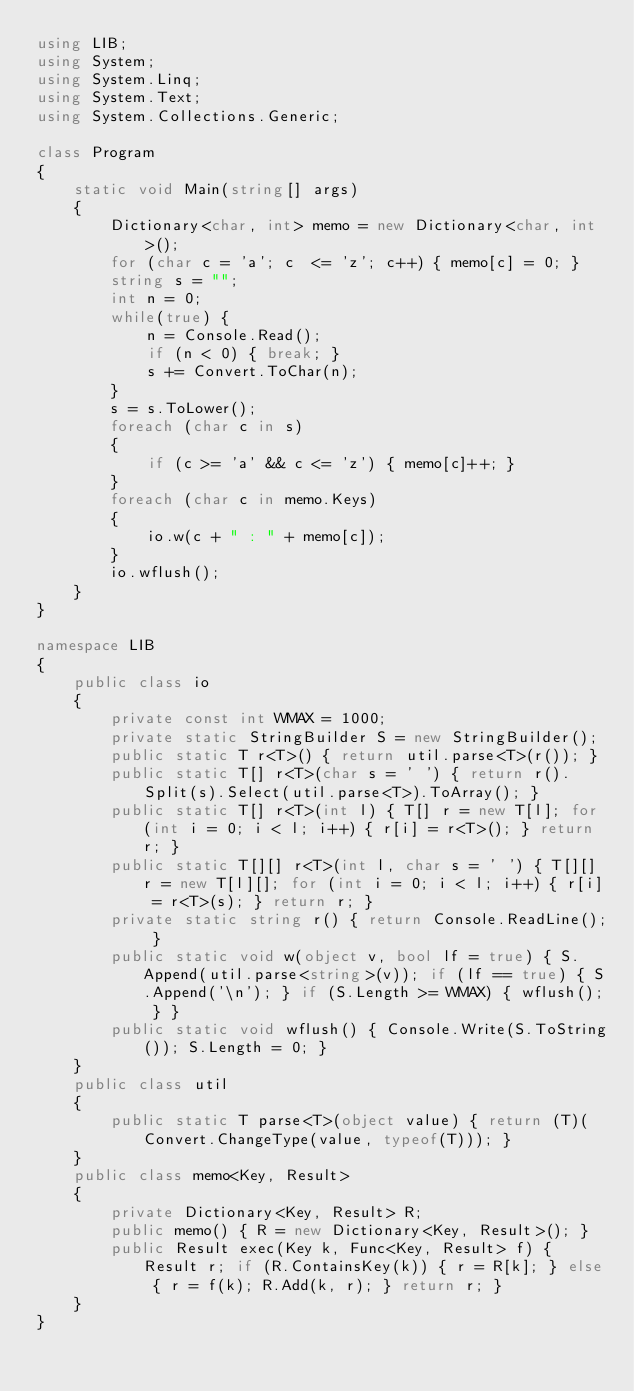<code> <loc_0><loc_0><loc_500><loc_500><_C#_>using LIB;
using System;
using System.Linq;
using System.Text;
using System.Collections.Generic;

class Program
{
    static void Main(string[] args)
    {
        Dictionary<char, int> memo = new Dictionary<char, int>();
        for (char c = 'a'; c  <= 'z'; c++) { memo[c] = 0; } 
        string s = "";
        int n = 0;
        while(true) {
            n = Console.Read();
            if (n < 0) { break; }
            s += Convert.ToChar(n);
        }
        s = s.ToLower();
        foreach (char c in s)
        {
            if (c >= 'a' && c <= 'z') { memo[c]++; }
        }
        foreach (char c in memo.Keys)
        {
            io.w(c + " : " + memo[c]);
        }
        io.wflush();
    }
}

namespace LIB
{
    public class io
    {
        private const int WMAX = 1000;
        private static StringBuilder S = new StringBuilder();
        public static T r<T>() { return util.parse<T>(r()); }
        public static T[] r<T>(char s = ' ') { return r().Split(s).Select(util.parse<T>).ToArray(); }
        public static T[] r<T>(int l) { T[] r = new T[l]; for (int i = 0; i < l; i++) { r[i] = r<T>(); } return r; }
        public static T[][] r<T>(int l, char s = ' ') { T[][] r = new T[l][]; for (int i = 0; i < l; i++) { r[i] = r<T>(s); } return r; }
        private static string r() { return Console.ReadLine(); }
        public static void w(object v, bool lf = true) { S.Append(util.parse<string>(v)); if (lf == true) { S.Append('\n'); } if (S.Length >= WMAX) { wflush(); } }
        public static void wflush() { Console.Write(S.ToString()); S.Length = 0; }
    }
    public class util
    {
        public static T parse<T>(object value) { return (T)(Convert.ChangeType(value, typeof(T))); }
    }
    public class memo<Key, Result>
    {
        private Dictionary<Key, Result> R;
        public memo() { R = new Dictionary<Key, Result>(); }
        public Result exec(Key k, Func<Key, Result> f) { Result r; if (R.ContainsKey(k)) { r = R[k]; } else { r = f(k); R.Add(k, r); } return r; }
    }
}</code> 